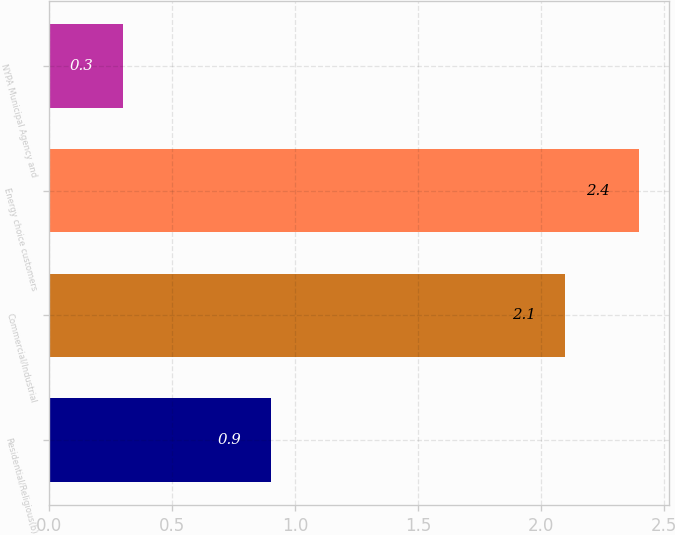Convert chart. <chart><loc_0><loc_0><loc_500><loc_500><bar_chart><fcel>Residential/Religious(b)<fcel>Commercial/Industrial<fcel>Energy choice customers<fcel>NYPA Municipal Agency and<nl><fcel>0.9<fcel>2.1<fcel>2.4<fcel>0.3<nl></chart> 